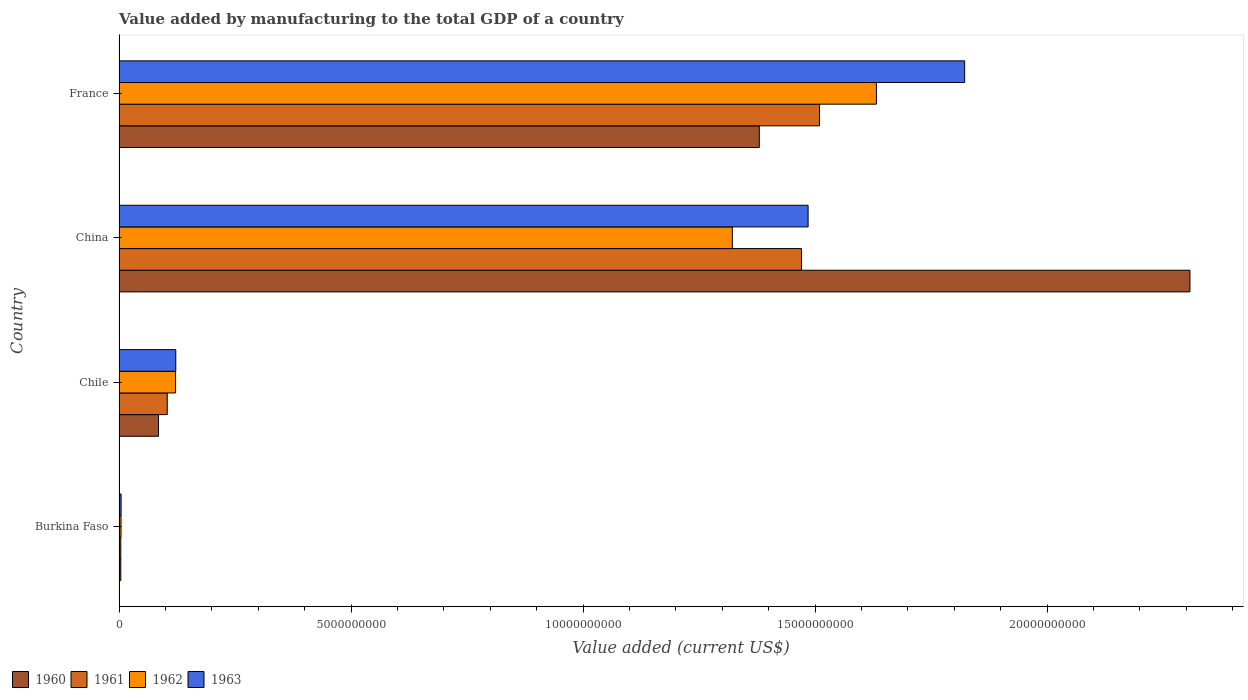How many different coloured bars are there?
Give a very brief answer. 4. Are the number of bars per tick equal to the number of legend labels?
Offer a very short reply. Yes. Are the number of bars on each tick of the Y-axis equal?
Provide a succinct answer. Yes. How many bars are there on the 1st tick from the bottom?
Offer a very short reply. 4. What is the label of the 4th group of bars from the top?
Keep it short and to the point. Burkina Faso. What is the value added by manufacturing to the total GDP in 1962 in France?
Make the answer very short. 1.63e+1. Across all countries, what is the maximum value added by manufacturing to the total GDP in 1963?
Give a very brief answer. 1.82e+1. Across all countries, what is the minimum value added by manufacturing to the total GDP in 1963?
Give a very brief answer. 4.39e+07. In which country was the value added by manufacturing to the total GDP in 1962 minimum?
Give a very brief answer. Burkina Faso. What is the total value added by manufacturing to the total GDP in 1961 in the graph?
Provide a short and direct response. 3.09e+1. What is the difference between the value added by manufacturing to the total GDP in 1960 in Burkina Faso and that in Chile?
Make the answer very short. -8.13e+08. What is the difference between the value added by manufacturing to the total GDP in 1963 in Chile and the value added by manufacturing to the total GDP in 1962 in Burkina Faso?
Ensure brevity in your answer.  1.18e+09. What is the average value added by manufacturing to the total GDP in 1960 per country?
Your answer should be very brief. 9.44e+09. What is the difference between the value added by manufacturing to the total GDP in 1960 and value added by manufacturing to the total GDP in 1962 in Chile?
Your answer should be very brief. -3.68e+08. What is the ratio of the value added by manufacturing to the total GDP in 1963 in Burkina Faso to that in Chile?
Provide a succinct answer. 0.04. Is the value added by manufacturing to the total GDP in 1961 in Burkina Faso less than that in France?
Your answer should be compact. Yes. What is the difference between the highest and the second highest value added by manufacturing to the total GDP in 1961?
Provide a short and direct response. 3.87e+08. What is the difference between the highest and the lowest value added by manufacturing to the total GDP in 1961?
Provide a short and direct response. 1.51e+1. What does the 3rd bar from the bottom in Burkina Faso represents?
Keep it short and to the point. 1962. Is it the case that in every country, the sum of the value added by manufacturing to the total GDP in 1962 and value added by manufacturing to the total GDP in 1961 is greater than the value added by manufacturing to the total GDP in 1960?
Your answer should be compact. Yes. How many bars are there?
Provide a succinct answer. 16. How many countries are there in the graph?
Ensure brevity in your answer.  4. What is the difference between two consecutive major ticks on the X-axis?
Provide a succinct answer. 5.00e+09. Are the values on the major ticks of X-axis written in scientific E-notation?
Ensure brevity in your answer.  No. How are the legend labels stacked?
Your answer should be very brief. Horizontal. What is the title of the graph?
Your response must be concise. Value added by manufacturing to the total GDP of a country. Does "1994" appear as one of the legend labels in the graph?
Offer a terse response. No. What is the label or title of the X-axis?
Keep it short and to the point. Value added (current US$). What is the Value added (current US$) in 1960 in Burkina Faso?
Give a very brief answer. 3.72e+07. What is the Value added (current US$) in 1961 in Burkina Faso?
Your answer should be compact. 3.72e+07. What is the Value added (current US$) in 1962 in Burkina Faso?
Make the answer very short. 4.22e+07. What is the Value added (current US$) of 1963 in Burkina Faso?
Your answer should be compact. 4.39e+07. What is the Value added (current US$) of 1960 in Chile?
Offer a terse response. 8.51e+08. What is the Value added (current US$) in 1961 in Chile?
Give a very brief answer. 1.04e+09. What is the Value added (current US$) of 1962 in Chile?
Provide a succinct answer. 1.22e+09. What is the Value added (current US$) of 1963 in Chile?
Provide a succinct answer. 1.22e+09. What is the Value added (current US$) in 1960 in China?
Your answer should be very brief. 2.31e+1. What is the Value added (current US$) of 1961 in China?
Offer a terse response. 1.47e+1. What is the Value added (current US$) in 1962 in China?
Your answer should be very brief. 1.32e+1. What is the Value added (current US$) in 1963 in China?
Your answer should be compact. 1.49e+1. What is the Value added (current US$) in 1960 in France?
Provide a succinct answer. 1.38e+1. What is the Value added (current US$) of 1961 in France?
Provide a short and direct response. 1.51e+1. What is the Value added (current US$) in 1962 in France?
Ensure brevity in your answer.  1.63e+1. What is the Value added (current US$) of 1963 in France?
Your response must be concise. 1.82e+1. Across all countries, what is the maximum Value added (current US$) of 1960?
Make the answer very short. 2.31e+1. Across all countries, what is the maximum Value added (current US$) of 1961?
Your response must be concise. 1.51e+1. Across all countries, what is the maximum Value added (current US$) of 1962?
Provide a short and direct response. 1.63e+1. Across all countries, what is the maximum Value added (current US$) of 1963?
Your response must be concise. 1.82e+1. Across all countries, what is the minimum Value added (current US$) of 1960?
Your answer should be very brief. 3.72e+07. Across all countries, what is the minimum Value added (current US$) of 1961?
Make the answer very short. 3.72e+07. Across all countries, what is the minimum Value added (current US$) of 1962?
Offer a terse response. 4.22e+07. Across all countries, what is the minimum Value added (current US$) in 1963?
Your answer should be very brief. 4.39e+07. What is the total Value added (current US$) of 1960 in the graph?
Offer a very short reply. 3.78e+1. What is the total Value added (current US$) in 1961 in the graph?
Offer a terse response. 3.09e+1. What is the total Value added (current US$) in 1962 in the graph?
Ensure brevity in your answer.  3.08e+1. What is the total Value added (current US$) of 1963 in the graph?
Provide a short and direct response. 3.43e+1. What is the difference between the Value added (current US$) of 1960 in Burkina Faso and that in Chile?
Keep it short and to the point. -8.13e+08. What is the difference between the Value added (current US$) in 1961 in Burkina Faso and that in Chile?
Ensure brevity in your answer.  -1.00e+09. What is the difference between the Value added (current US$) in 1962 in Burkina Faso and that in Chile?
Offer a very short reply. -1.18e+09. What is the difference between the Value added (current US$) of 1963 in Burkina Faso and that in Chile?
Keep it short and to the point. -1.18e+09. What is the difference between the Value added (current US$) of 1960 in Burkina Faso and that in China?
Make the answer very short. -2.30e+1. What is the difference between the Value added (current US$) in 1961 in Burkina Faso and that in China?
Your answer should be compact. -1.47e+1. What is the difference between the Value added (current US$) of 1962 in Burkina Faso and that in China?
Your answer should be compact. -1.32e+1. What is the difference between the Value added (current US$) of 1963 in Burkina Faso and that in China?
Ensure brevity in your answer.  -1.48e+1. What is the difference between the Value added (current US$) of 1960 in Burkina Faso and that in France?
Provide a short and direct response. -1.38e+1. What is the difference between the Value added (current US$) of 1961 in Burkina Faso and that in France?
Your answer should be very brief. -1.51e+1. What is the difference between the Value added (current US$) in 1962 in Burkina Faso and that in France?
Make the answer very short. -1.63e+1. What is the difference between the Value added (current US$) of 1963 in Burkina Faso and that in France?
Keep it short and to the point. -1.82e+1. What is the difference between the Value added (current US$) in 1960 in Chile and that in China?
Your answer should be very brief. -2.22e+1. What is the difference between the Value added (current US$) in 1961 in Chile and that in China?
Keep it short and to the point. -1.37e+1. What is the difference between the Value added (current US$) of 1962 in Chile and that in China?
Your response must be concise. -1.20e+1. What is the difference between the Value added (current US$) in 1963 in Chile and that in China?
Give a very brief answer. -1.36e+1. What is the difference between the Value added (current US$) of 1960 in Chile and that in France?
Offer a very short reply. -1.29e+1. What is the difference between the Value added (current US$) of 1961 in Chile and that in France?
Your response must be concise. -1.41e+1. What is the difference between the Value added (current US$) of 1962 in Chile and that in France?
Provide a succinct answer. -1.51e+1. What is the difference between the Value added (current US$) of 1963 in Chile and that in France?
Provide a succinct answer. -1.70e+1. What is the difference between the Value added (current US$) of 1960 in China and that in France?
Keep it short and to the point. 9.28e+09. What is the difference between the Value added (current US$) in 1961 in China and that in France?
Offer a very short reply. -3.87e+08. What is the difference between the Value added (current US$) of 1962 in China and that in France?
Offer a terse response. -3.11e+09. What is the difference between the Value added (current US$) in 1963 in China and that in France?
Your response must be concise. -3.37e+09. What is the difference between the Value added (current US$) in 1960 in Burkina Faso and the Value added (current US$) in 1961 in Chile?
Make the answer very short. -1.00e+09. What is the difference between the Value added (current US$) of 1960 in Burkina Faso and the Value added (current US$) of 1962 in Chile?
Ensure brevity in your answer.  -1.18e+09. What is the difference between the Value added (current US$) in 1960 in Burkina Faso and the Value added (current US$) in 1963 in Chile?
Offer a very short reply. -1.19e+09. What is the difference between the Value added (current US$) of 1961 in Burkina Faso and the Value added (current US$) of 1962 in Chile?
Provide a short and direct response. -1.18e+09. What is the difference between the Value added (current US$) in 1961 in Burkina Faso and the Value added (current US$) in 1963 in Chile?
Offer a very short reply. -1.19e+09. What is the difference between the Value added (current US$) in 1962 in Burkina Faso and the Value added (current US$) in 1963 in Chile?
Keep it short and to the point. -1.18e+09. What is the difference between the Value added (current US$) of 1960 in Burkina Faso and the Value added (current US$) of 1961 in China?
Make the answer very short. -1.47e+1. What is the difference between the Value added (current US$) of 1960 in Burkina Faso and the Value added (current US$) of 1962 in China?
Offer a terse response. -1.32e+1. What is the difference between the Value added (current US$) of 1960 in Burkina Faso and the Value added (current US$) of 1963 in China?
Ensure brevity in your answer.  -1.48e+1. What is the difference between the Value added (current US$) in 1961 in Burkina Faso and the Value added (current US$) in 1962 in China?
Offer a very short reply. -1.32e+1. What is the difference between the Value added (current US$) in 1961 in Burkina Faso and the Value added (current US$) in 1963 in China?
Your answer should be compact. -1.48e+1. What is the difference between the Value added (current US$) in 1962 in Burkina Faso and the Value added (current US$) in 1963 in China?
Provide a short and direct response. -1.48e+1. What is the difference between the Value added (current US$) of 1960 in Burkina Faso and the Value added (current US$) of 1961 in France?
Your answer should be compact. -1.51e+1. What is the difference between the Value added (current US$) in 1960 in Burkina Faso and the Value added (current US$) in 1962 in France?
Give a very brief answer. -1.63e+1. What is the difference between the Value added (current US$) of 1960 in Burkina Faso and the Value added (current US$) of 1963 in France?
Offer a very short reply. -1.82e+1. What is the difference between the Value added (current US$) of 1961 in Burkina Faso and the Value added (current US$) of 1962 in France?
Make the answer very short. -1.63e+1. What is the difference between the Value added (current US$) of 1961 in Burkina Faso and the Value added (current US$) of 1963 in France?
Provide a short and direct response. -1.82e+1. What is the difference between the Value added (current US$) of 1962 in Burkina Faso and the Value added (current US$) of 1963 in France?
Your answer should be very brief. -1.82e+1. What is the difference between the Value added (current US$) of 1960 in Chile and the Value added (current US$) of 1961 in China?
Your answer should be very brief. -1.39e+1. What is the difference between the Value added (current US$) of 1960 in Chile and the Value added (current US$) of 1962 in China?
Your response must be concise. -1.24e+1. What is the difference between the Value added (current US$) in 1960 in Chile and the Value added (current US$) in 1963 in China?
Ensure brevity in your answer.  -1.40e+1. What is the difference between the Value added (current US$) in 1961 in Chile and the Value added (current US$) in 1962 in China?
Your response must be concise. -1.22e+1. What is the difference between the Value added (current US$) of 1961 in Chile and the Value added (current US$) of 1963 in China?
Your answer should be compact. -1.38e+1. What is the difference between the Value added (current US$) of 1962 in Chile and the Value added (current US$) of 1963 in China?
Provide a short and direct response. -1.36e+1. What is the difference between the Value added (current US$) of 1960 in Chile and the Value added (current US$) of 1961 in France?
Your answer should be very brief. -1.42e+1. What is the difference between the Value added (current US$) of 1960 in Chile and the Value added (current US$) of 1962 in France?
Provide a succinct answer. -1.55e+1. What is the difference between the Value added (current US$) of 1960 in Chile and the Value added (current US$) of 1963 in France?
Keep it short and to the point. -1.74e+1. What is the difference between the Value added (current US$) in 1961 in Chile and the Value added (current US$) in 1962 in France?
Provide a succinct answer. -1.53e+1. What is the difference between the Value added (current US$) of 1961 in Chile and the Value added (current US$) of 1963 in France?
Ensure brevity in your answer.  -1.72e+1. What is the difference between the Value added (current US$) of 1962 in Chile and the Value added (current US$) of 1963 in France?
Offer a terse response. -1.70e+1. What is the difference between the Value added (current US$) in 1960 in China and the Value added (current US$) in 1961 in France?
Your response must be concise. 7.98e+09. What is the difference between the Value added (current US$) in 1960 in China and the Value added (current US$) in 1962 in France?
Offer a very short reply. 6.76e+09. What is the difference between the Value added (current US$) in 1960 in China and the Value added (current US$) in 1963 in France?
Provide a short and direct response. 4.86e+09. What is the difference between the Value added (current US$) of 1961 in China and the Value added (current US$) of 1962 in France?
Give a very brief answer. -1.61e+09. What is the difference between the Value added (current US$) in 1961 in China and the Value added (current US$) in 1963 in France?
Provide a short and direct response. -3.52e+09. What is the difference between the Value added (current US$) in 1962 in China and the Value added (current US$) in 1963 in France?
Provide a short and direct response. -5.01e+09. What is the average Value added (current US$) of 1960 per country?
Make the answer very short. 9.44e+09. What is the average Value added (current US$) of 1961 per country?
Your answer should be compact. 7.72e+09. What is the average Value added (current US$) of 1962 per country?
Provide a short and direct response. 7.70e+09. What is the average Value added (current US$) of 1963 per country?
Your answer should be very brief. 8.59e+09. What is the difference between the Value added (current US$) in 1960 and Value added (current US$) in 1961 in Burkina Faso?
Ensure brevity in your answer.  9866.11. What is the difference between the Value added (current US$) of 1960 and Value added (current US$) of 1962 in Burkina Faso?
Provide a short and direct response. -5.00e+06. What is the difference between the Value added (current US$) in 1960 and Value added (current US$) in 1963 in Burkina Faso?
Provide a succinct answer. -6.65e+06. What is the difference between the Value added (current US$) of 1961 and Value added (current US$) of 1962 in Burkina Faso?
Provide a succinct answer. -5.01e+06. What is the difference between the Value added (current US$) of 1961 and Value added (current US$) of 1963 in Burkina Faso?
Make the answer very short. -6.66e+06. What is the difference between the Value added (current US$) in 1962 and Value added (current US$) in 1963 in Burkina Faso?
Provide a succinct answer. -1.65e+06. What is the difference between the Value added (current US$) of 1960 and Value added (current US$) of 1961 in Chile?
Ensure brevity in your answer.  -1.88e+08. What is the difference between the Value added (current US$) in 1960 and Value added (current US$) in 1962 in Chile?
Make the answer very short. -3.68e+08. What is the difference between the Value added (current US$) in 1960 and Value added (current US$) in 1963 in Chile?
Give a very brief answer. -3.72e+08. What is the difference between the Value added (current US$) of 1961 and Value added (current US$) of 1962 in Chile?
Ensure brevity in your answer.  -1.80e+08. What is the difference between the Value added (current US$) in 1961 and Value added (current US$) in 1963 in Chile?
Your answer should be compact. -1.84e+08. What is the difference between the Value added (current US$) of 1962 and Value added (current US$) of 1963 in Chile?
Offer a very short reply. -4.28e+06. What is the difference between the Value added (current US$) in 1960 and Value added (current US$) in 1961 in China?
Give a very brief answer. 8.37e+09. What is the difference between the Value added (current US$) of 1960 and Value added (current US$) of 1962 in China?
Your answer should be compact. 9.86e+09. What is the difference between the Value added (current US$) in 1960 and Value added (current US$) in 1963 in China?
Keep it short and to the point. 8.23e+09. What is the difference between the Value added (current US$) in 1961 and Value added (current US$) in 1962 in China?
Make the answer very short. 1.49e+09. What is the difference between the Value added (current US$) in 1961 and Value added (current US$) in 1963 in China?
Ensure brevity in your answer.  -1.42e+08. What is the difference between the Value added (current US$) in 1962 and Value added (current US$) in 1963 in China?
Your answer should be compact. -1.63e+09. What is the difference between the Value added (current US$) in 1960 and Value added (current US$) in 1961 in France?
Offer a terse response. -1.30e+09. What is the difference between the Value added (current US$) of 1960 and Value added (current US$) of 1962 in France?
Provide a succinct answer. -2.52e+09. What is the difference between the Value added (current US$) in 1960 and Value added (current US$) in 1963 in France?
Your answer should be very brief. -4.43e+09. What is the difference between the Value added (current US$) in 1961 and Value added (current US$) in 1962 in France?
Ensure brevity in your answer.  -1.23e+09. What is the difference between the Value added (current US$) of 1961 and Value added (current US$) of 1963 in France?
Your answer should be very brief. -3.13e+09. What is the difference between the Value added (current US$) of 1962 and Value added (current US$) of 1963 in France?
Provide a succinct answer. -1.90e+09. What is the ratio of the Value added (current US$) in 1960 in Burkina Faso to that in Chile?
Offer a terse response. 0.04. What is the ratio of the Value added (current US$) of 1961 in Burkina Faso to that in Chile?
Offer a very short reply. 0.04. What is the ratio of the Value added (current US$) of 1962 in Burkina Faso to that in Chile?
Your answer should be very brief. 0.03. What is the ratio of the Value added (current US$) of 1963 in Burkina Faso to that in Chile?
Keep it short and to the point. 0.04. What is the ratio of the Value added (current US$) of 1960 in Burkina Faso to that in China?
Make the answer very short. 0. What is the ratio of the Value added (current US$) in 1961 in Burkina Faso to that in China?
Keep it short and to the point. 0. What is the ratio of the Value added (current US$) of 1962 in Burkina Faso to that in China?
Offer a terse response. 0. What is the ratio of the Value added (current US$) in 1963 in Burkina Faso to that in China?
Your answer should be compact. 0. What is the ratio of the Value added (current US$) of 1960 in Burkina Faso to that in France?
Provide a short and direct response. 0. What is the ratio of the Value added (current US$) of 1961 in Burkina Faso to that in France?
Provide a short and direct response. 0. What is the ratio of the Value added (current US$) of 1962 in Burkina Faso to that in France?
Offer a terse response. 0. What is the ratio of the Value added (current US$) of 1963 in Burkina Faso to that in France?
Give a very brief answer. 0. What is the ratio of the Value added (current US$) in 1960 in Chile to that in China?
Make the answer very short. 0.04. What is the ratio of the Value added (current US$) of 1961 in Chile to that in China?
Your response must be concise. 0.07. What is the ratio of the Value added (current US$) in 1962 in Chile to that in China?
Your answer should be compact. 0.09. What is the ratio of the Value added (current US$) of 1963 in Chile to that in China?
Provide a short and direct response. 0.08. What is the ratio of the Value added (current US$) of 1960 in Chile to that in France?
Your answer should be compact. 0.06. What is the ratio of the Value added (current US$) in 1961 in Chile to that in France?
Keep it short and to the point. 0.07. What is the ratio of the Value added (current US$) in 1962 in Chile to that in France?
Your response must be concise. 0.07. What is the ratio of the Value added (current US$) in 1963 in Chile to that in France?
Offer a terse response. 0.07. What is the ratio of the Value added (current US$) in 1960 in China to that in France?
Your response must be concise. 1.67. What is the ratio of the Value added (current US$) of 1961 in China to that in France?
Your answer should be compact. 0.97. What is the ratio of the Value added (current US$) in 1962 in China to that in France?
Your answer should be compact. 0.81. What is the ratio of the Value added (current US$) in 1963 in China to that in France?
Your answer should be compact. 0.81. What is the difference between the highest and the second highest Value added (current US$) in 1960?
Your response must be concise. 9.28e+09. What is the difference between the highest and the second highest Value added (current US$) in 1961?
Offer a very short reply. 3.87e+08. What is the difference between the highest and the second highest Value added (current US$) in 1962?
Keep it short and to the point. 3.11e+09. What is the difference between the highest and the second highest Value added (current US$) in 1963?
Offer a terse response. 3.37e+09. What is the difference between the highest and the lowest Value added (current US$) in 1960?
Keep it short and to the point. 2.30e+1. What is the difference between the highest and the lowest Value added (current US$) in 1961?
Give a very brief answer. 1.51e+1. What is the difference between the highest and the lowest Value added (current US$) of 1962?
Provide a succinct answer. 1.63e+1. What is the difference between the highest and the lowest Value added (current US$) of 1963?
Your answer should be very brief. 1.82e+1. 